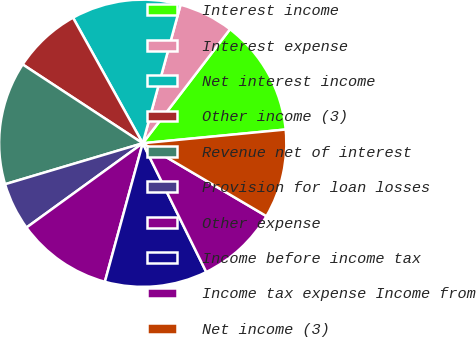Convert chart. <chart><loc_0><loc_0><loc_500><loc_500><pie_chart><fcel>Interest income<fcel>Interest expense<fcel>Net interest income<fcel>Other income (3)<fcel>Revenue net of interest<fcel>Provision for loan losses<fcel>Other expense<fcel>Income before income tax<fcel>Income tax expense Income from<fcel>Net income (3)<nl><fcel>13.08%<fcel>6.15%<fcel>12.31%<fcel>7.69%<fcel>13.85%<fcel>5.38%<fcel>10.77%<fcel>11.54%<fcel>9.23%<fcel>10.0%<nl></chart> 